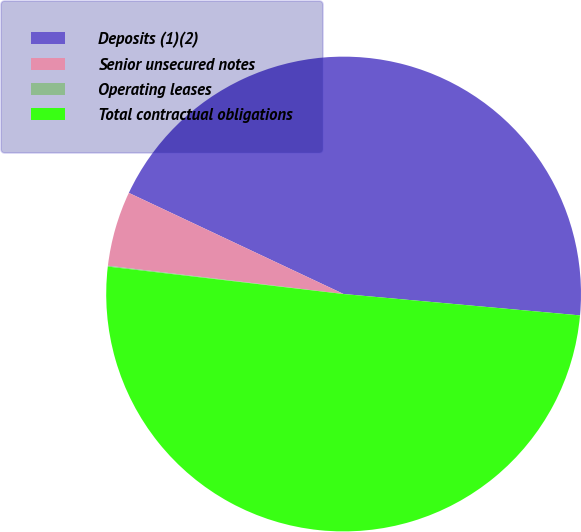<chart> <loc_0><loc_0><loc_500><loc_500><pie_chart><fcel>Deposits (1)(2)<fcel>Senior unsecured notes<fcel>Operating leases<fcel>Total contractual obligations<nl><fcel>44.43%<fcel>5.1%<fcel>0.06%<fcel>50.41%<nl></chart> 